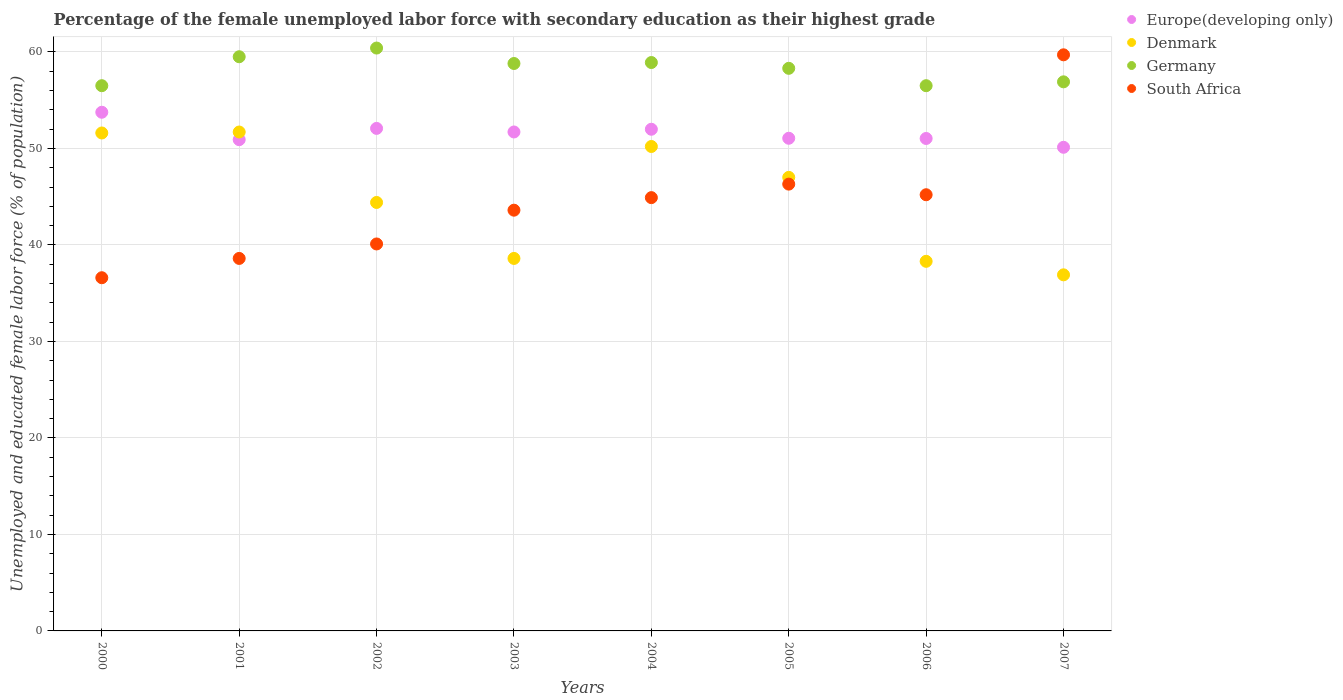What is the percentage of the unemployed female labor force with secondary education in Europe(developing only) in 2003?
Your answer should be compact. 51.71. Across all years, what is the maximum percentage of the unemployed female labor force with secondary education in Europe(developing only)?
Keep it short and to the point. 53.75. Across all years, what is the minimum percentage of the unemployed female labor force with secondary education in Germany?
Provide a succinct answer. 56.5. In which year was the percentage of the unemployed female labor force with secondary education in South Africa maximum?
Give a very brief answer. 2007. In which year was the percentage of the unemployed female labor force with secondary education in Europe(developing only) minimum?
Your answer should be compact. 2007. What is the total percentage of the unemployed female labor force with secondary education in Germany in the graph?
Your response must be concise. 465.8. What is the difference between the percentage of the unemployed female labor force with secondary education in Denmark in 2001 and that in 2002?
Your answer should be compact. 7.3. What is the difference between the percentage of the unemployed female labor force with secondary education in South Africa in 2004 and the percentage of the unemployed female labor force with secondary education in Europe(developing only) in 2003?
Offer a terse response. -6.81. What is the average percentage of the unemployed female labor force with secondary education in Germany per year?
Your response must be concise. 58.23. In how many years, is the percentage of the unemployed female labor force with secondary education in Europe(developing only) greater than 4 %?
Offer a terse response. 8. What is the ratio of the percentage of the unemployed female labor force with secondary education in Germany in 2002 to that in 2006?
Give a very brief answer. 1.07. What is the difference between the highest and the second highest percentage of the unemployed female labor force with secondary education in South Africa?
Make the answer very short. 13.4. What is the difference between the highest and the lowest percentage of the unemployed female labor force with secondary education in Europe(developing only)?
Offer a terse response. 3.63. Is the sum of the percentage of the unemployed female labor force with secondary education in Germany in 2005 and 2006 greater than the maximum percentage of the unemployed female labor force with secondary education in Denmark across all years?
Offer a terse response. Yes. Is it the case that in every year, the sum of the percentage of the unemployed female labor force with secondary education in Denmark and percentage of the unemployed female labor force with secondary education in South Africa  is greater than the sum of percentage of the unemployed female labor force with secondary education in Germany and percentage of the unemployed female labor force with secondary education in Europe(developing only)?
Provide a succinct answer. Yes. Is it the case that in every year, the sum of the percentage of the unemployed female labor force with secondary education in South Africa and percentage of the unemployed female labor force with secondary education in Europe(developing only)  is greater than the percentage of the unemployed female labor force with secondary education in Denmark?
Offer a very short reply. Yes. Does the percentage of the unemployed female labor force with secondary education in Germany monotonically increase over the years?
Your answer should be compact. No. Is the percentage of the unemployed female labor force with secondary education in Denmark strictly greater than the percentage of the unemployed female labor force with secondary education in South Africa over the years?
Offer a very short reply. No. How many years are there in the graph?
Your response must be concise. 8. What is the difference between two consecutive major ticks on the Y-axis?
Make the answer very short. 10. Does the graph contain any zero values?
Make the answer very short. No. What is the title of the graph?
Your answer should be very brief. Percentage of the female unemployed labor force with secondary education as their highest grade. What is the label or title of the X-axis?
Your response must be concise. Years. What is the label or title of the Y-axis?
Make the answer very short. Unemployed and educated female labor force (% of population). What is the Unemployed and educated female labor force (% of population) of Europe(developing only) in 2000?
Ensure brevity in your answer.  53.75. What is the Unemployed and educated female labor force (% of population) of Denmark in 2000?
Your answer should be very brief. 51.6. What is the Unemployed and educated female labor force (% of population) of Germany in 2000?
Provide a succinct answer. 56.5. What is the Unemployed and educated female labor force (% of population) of South Africa in 2000?
Keep it short and to the point. 36.6. What is the Unemployed and educated female labor force (% of population) in Europe(developing only) in 2001?
Provide a succinct answer. 50.91. What is the Unemployed and educated female labor force (% of population) in Denmark in 2001?
Ensure brevity in your answer.  51.7. What is the Unemployed and educated female labor force (% of population) of Germany in 2001?
Give a very brief answer. 59.5. What is the Unemployed and educated female labor force (% of population) of South Africa in 2001?
Give a very brief answer. 38.6. What is the Unemployed and educated female labor force (% of population) of Europe(developing only) in 2002?
Your response must be concise. 52.07. What is the Unemployed and educated female labor force (% of population) in Denmark in 2002?
Your answer should be compact. 44.4. What is the Unemployed and educated female labor force (% of population) in Germany in 2002?
Your answer should be compact. 60.4. What is the Unemployed and educated female labor force (% of population) of South Africa in 2002?
Your answer should be compact. 40.1. What is the Unemployed and educated female labor force (% of population) in Europe(developing only) in 2003?
Offer a very short reply. 51.71. What is the Unemployed and educated female labor force (% of population) of Denmark in 2003?
Offer a terse response. 38.6. What is the Unemployed and educated female labor force (% of population) in Germany in 2003?
Make the answer very short. 58.8. What is the Unemployed and educated female labor force (% of population) in South Africa in 2003?
Give a very brief answer. 43.6. What is the Unemployed and educated female labor force (% of population) of Europe(developing only) in 2004?
Keep it short and to the point. 51.99. What is the Unemployed and educated female labor force (% of population) in Denmark in 2004?
Offer a terse response. 50.2. What is the Unemployed and educated female labor force (% of population) of Germany in 2004?
Provide a succinct answer. 58.9. What is the Unemployed and educated female labor force (% of population) of South Africa in 2004?
Give a very brief answer. 44.9. What is the Unemployed and educated female labor force (% of population) in Europe(developing only) in 2005?
Make the answer very short. 51.05. What is the Unemployed and educated female labor force (% of population) in Germany in 2005?
Your answer should be compact. 58.3. What is the Unemployed and educated female labor force (% of population) of South Africa in 2005?
Give a very brief answer. 46.3. What is the Unemployed and educated female labor force (% of population) in Europe(developing only) in 2006?
Keep it short and to the point. 51.03. What is the Unemployed and educated female labor force (% of population) in Denmark in 2006?
Ensure brevity in your answer.  38.3. What is the Unemployed and educated female labor force (% of population) in Germany in 2006?
Offer a very short reply. 56.5. What is the Unemployed and educated female labor force (% of population) of South Africa in 2006?
Make the answer very short. 45.2. What is the Unemployed and educated female labor force (% of population) in Europe(developing only) in 2007?
Ensure brevity in your answer.  50.12. What is the Unemployed and educated female labor force (% of population) of Denmark in 2007?
Your answer should be very brief. 36.9. What is the Unemployed and educated female labor force (% of population) in Germany in 2007?
Ensure brevity in your answer.  56.9. What is the Unemployed and educated female labor force (% of population) of South Africa in 2007?
Provide a succinct answer. 59.7. Across all years, what is the maximum Unemployed and educated female labor force (% of population) of Europe(developing only)?
Your answer should be compact. 53.75. Across all years, what is the maximum Unemployed and educated female labor force (% of population) of Denmark?
Make the answer very short. 51.7. Across all years, what is the maximum Unemployed and educated female labor force (% of population) in Germany?
Provide a succinct answer. 60.4. Across all years, what is the maximum Unemployed and educated female labor force (% of population) in South Africa?
Keep it short and to the point. 59.7. Across all years, what is the minimum Unemployed and educated female labor force (% of population) of Europe(developing only)?
Keep it short and to the point. 50.12. Across all years, what is the minimum Unemployed and educated female labor force (% of population) in Denmark?
Your response must be concise. 36.9. Across all years, what is the minimum Unemployed and educated female labor force (% of population) in Germany?
Make the answer very short. 56.5. Across all years, what is the minimum Unemployed and educated female labor force (% of population) of South Africa?
Make the answer very short. 36.6. What is the total Unemployed and educated female labor force (% of population) in Europe(developing only) in the graph?
Make the answer very short. 412.62. What is the total Unemployed and educated female labor force (% of population) of Denmark in the graph?
Give a very brief answer. 358.7. What is the total Unemployed and educated female labor force (% of population) in Germany in the graph?
Give a very brief answer. 465.8. What is the total Unemployed and educated female labor force (% of population) of South Africa in the graph?
Offer a terse response. 355. What is the difference between the Unemployed and educated female labor force (% of population) of Europe(developing only) in 2000 and that in 2001?
Offer a very short reply. 2.84. What is the difference between the Unemployed and educated female labor force (% of population) of Germany in 2000 and that in 2001?
Make the answer very short. -3. What is the difference between the Unemployed and educated female labor force (% of population) of South Africa in 2000 and that in 2001?
Offer a terse response. -2. What is the difference between the Unemployed and educated female labor force (% of population) in Europe(developing only) in 2000 and that in 2002?
Ensure brevity in your answer.  1.67. What is the difference between the Unemployed and educated female labor force (% of population) in Denmark in 2000 and that in 2002?
Your answer should be very brief. 7.2. What is the difference between the Unemployed and educated female labor force (% of population) in Germany in 2000 and that in 2002?
Provide a succinct answer. -3.9. What is the difference between the Unemployed and educated female labor force (% of population) of Europe(developing only) in 2000 and that in 2003?
Your answer should be very brief. 2.04. What is the difference between the Unemployed and educated female labor force (% of population) in Denmark in 2000 and that in 2003?
Provide a short and direct response. 13. What is the difference between the Unemployed and educated female labor force (% of population) of South Africa in 2000 and that in 2003?
Keep it short and to the point. -7. What is the difference between the Unemployed and educated female labor force (% of population) of Europe(developing only) in 2000 and that in 2004?
Your response must be concise. 1.76. What is the difference between the Unemployed and educated female labor force (% of population) of Germany in 2000 and that in 2004?
Your answer should be very brief. -2.4. What is the difference between the Unemployed and educated female labor force (% of population) in South Africa in 2000 and that in 2004?
Offer a very short reply. -8.3. What is the difference between the Unemployed and educated female labor force (% of population) in Europe(developing only) in 2000 and that in 2005?
Offer a terse response. 2.7. What is the difference between the Unemployed and educated female labor force (% of population) of Europe(developing only) in 2000 and that in 2006?
Keep it short and to the point. 2.72. What is the difference between the Unemployed and educated female labor force (% of population) of Europe(developing only) in 2000 and that in 2007?
Make the answer very short. 3.63. What is the difference between the Unemployed and educated female labor force (% of population) in Denmark in 2000 and that in 2007?
Offer a very short reply. 14.7. What is the difference between the Unemployed and educated female labor force (% of population) in Germany in 2000 and that in 2007?
Ensure brevity in your answer.  -0.4. What is the difference between the Unemployed and educated female labor force (% of population) of South Africa in 2000 and that in 2007?
Offer a very short reply. -23.1. What is the difference between the Unemployed and educated female labor force (% of population) of Europe(developing only) in 2001 and that in 2002?
Provide a short and direct response. -1.17. What is the difference between the Unemployed and educated female labor force (% of population) of South Africa in 2001 and that in 2002?
Provide a short and direct response. -1.5. What is the difference between the Unemployed and educated female labor force (% of population) of Europe(developing only) in 2001 and that in 2003?
Offer a very short reply. -0.8. What is the difference between the Unemployed and educated female labor force (% of population) in Denmark in 2001 and that in 2003?
Your response must be concise. 13.1. What is the difference between the Unemployed and educated female labor force (% of population) of Europe(developing only) in 2001 and that in 2004?
Give a very brief answer. -1.08. What is the difference between the Unemployed and educated female labor force (% of population) in South Africa in 2001 and that in 2004?
Offer a very short reply. -6.3. What is the difference between the Unemployed and educated female labor force (% of population) of Europe(developing only) in 2001 and that in 2005?
Your answer should be compact. -0.15. What is the difference between the Unemployed and educated female labor force (% of population) of Germany in 2001 and that in 2005?
Offer a very short reply. 1.2. What is the difference between the Unemployed and educated female labor force (% of population) in Europe(developing only) in 2001 and that in 2006?
Your response must be concise. -0.12. What is the difference between the Unemployed and educated female labor force (% of population) in Germany in 2001 and that in 2006?
Offer a terse response. 3. What is the difference between the Unemployed and educated female labor force (% of population) of Europe(developing only) in 2001 and that in 2007?
Make the answer very short. 0.79. What is the difference between the Unemployed and educated female labor force (% of population) in South Africa in 2001 and that in 2007?
Your answer should be compact. -21.1. What is the difference between the Unemployed and educated female labor force (% of population) in Europe(developing only) in 2002 and that in 2003?
Your answer should be very brief. 0.37. What is the difference between the Unemployed and educated female labor force (% of population) of Denmark in 2002 and that in 2003?
Make the answer very short. 5.8. What is the difference between the Unemployed and educated female labor force (% of population) in Europe(developing only) in 2002 and that in 2004?
Provide a short and direct response. 0.09. What is the difference between the Unemployed and educated female labor force (% of population) in Germany in 2002 and that in 2004?
Offer a terse response. 1.5. What is the difference between the Unemployed and educated female labor force (% of population) in Denmark in 2002 and that in 2005?
Keep it short and to the point. -2.6. What is the difference between the Unemployed and educated female labor force (% of population) in Germany in 2002 and that in 2005?
Your response must be concise. 2.1. What is the difference between the Unemployed and educated female labor force (% of population) of South Africa in 2002 and that in 2005?
Your answer should be compact. -6.2. What is the difference between the Unemployed and educated female labor force (% of population) in Europe(developing only) in 2002 and that in 2006?
Your answer should be compact. 1.04. What is the difference between the Unemployed and educated female labor force (% of population) in Germany in 2002 and that in 2006?
Provide a succinct answer. 3.9. What is the difference between the Unemployed and educated female labor force (% of population) in Europe(developing only) in 2002 and that in 2007?
Offer a terse response. 1.96. What is the difference between the Unemployed and educated female labor force (% of population) of Denmark in 2002 and that in 2007?
Keep it short and to the point. 7.5. What is the difference between the Unemployed and educated female labor force (% of population) in South Africa in 2002 and that in 2007?
Keep it short and to the point. -19.6. What is the difference between the Unemployed and educated female labor force (% of population) in Europe(developing only) in 2003 and that in 2004?
Offer a very short reply. -0.28. What is the difference between the Unemployed and educated female labor force (% of population) in South Africa in 2003 and that in 2004?
Offer a terse response. -1.3. What is the difference between the Unemployed and educated female labor force (% of population) of Europe(developing only) in 2003 and that in 2005?
Offer a terse response. 0.65. What is the difference between the Unemployed and educated female labor force (% of population) of Europe(developing only) in 2003 and that in 2006?
Give a very brief answer. 0.67. What is the difference between the Unemployed and educated female labor force (% of population) of South Africa in 2003 and that in 2006?
Give a very brief answer. -1.6. What is the difference between the Unemployed and educated female labor force (% of population) in Europe(developing only) in 2003 and that in 2007?
Give a very brief answer. 1.59. What is the difference between the Unemployed and educated female labor force (% of population) in South Africa in 2003 and that in 2007?
Give a very brief answer. -16.1. What is the difference between the Unemployed and educated female labor force (% of population) of Europe(developing only) in 2004 and that in 2005?
Provide a succinct answer. 0.93. What is the difference between the Unemployed and educated female labor force (% of population) of South Africa in 2004 and that in 2005?
Offer a very short reply. -1.4. What is the difference between the Unemployed and educated female labor force (% of population) in Europe(developing only) in 2004 and that in 2006?
Give a very brief answer. 0.96. What is the difference between the Unemployed and educated female labor force (% of population) in Germany in 2004 and that in 2006?
Give a very brief answer. 2.4. What is the difference between the Unemployed and educated female labor force (% of population) of Europe(developing only) in 2004 and that in 2007?
Offer a terse response. 1.87. What is the difference between the Unemployed and educated female labor force (% of population) of Denmark in 2004 and that in 2007?
Provide a short and direct response. 13.3. What is the difference between the Unemployed and educated female labor force (% of population) in South Africa in 2004 and that in 2007?
Your answer should be compact. -14.8. What is the difference between the Unemployed and educated female labor force (% of population) of Europe(developing only) in 2005 and that in 2006?
Your answer should be very brief. 0.02. What is the difference between the Unemployed and educated female labor force (% of population) of Denmark in 2005 and that in 2006?
Make the answer very short. 8.7. What is the difference between the Unemployed and educated female labor force (% of population) in Germany in 2005 and that in 2006?
Offer a terse response. 1.8. What is the difference between the Unemployed and educated female labor force (% of population) in Europe(developing only) in 2005 and that in 2007?
Keep it short and to the point. 0.94. What is the difference between the Unemployed and educated female labor force (% of population) of Germany in 2005 and that in 2007?
Offer a very short reply. 1.4. What is the difference between the Unemployed and educated female labor force (% of population) of South Africa in 2005 and that in 2007?
Provide a short and direct response. -13.4. What is the difference between the Unemployed and educated female labor force (% of population) of Europe(developing only) in 2006 and that in 2007?
Give a very brief answer. 0.91. What is the difference between the Unemployed and educated female labor force (% of population) in Europe(developing only) in 2000 and the Unemployed and educated female labor force (% of population) in Denmark in 2001?
Provide a short and direct response. 2.05. What is the difference between the Unemployed and educated female labor force (% of population) of Europe(developing only) in 2000 and the Unemployed and educated female labor force (% of population) of Germany in 2001?
Provide a succinct answer. -5.75. What is the difference between the Unemployed and educated female labor force (% of population) in Europe(developing only) in 2000 and the Unemployed and educated female labor force (% of population) in South Africa in 2001?
Your answer should be compact. 15.15. What is the difference between the Unemployed and educated female labor force (% of population) in Denmark in 2000 and the Unemployed and educated female labor force (% of population) in South Africa in 2001?
Give a very brief answer. 13. What is the difference between the Unemployed and educated female labor force (% of population) of Europe(developing only) in 2000 and the Unemployed and educated female labor force (% of population) of Denmark in 2002?
Offer a very short reply. 9.35. What is the difference between the Unemployed and educated female labor force (% of population) in Europe(developing only) in 2000 and the Unemployed and educated female labor force (% of population) in Germany in 2002?
Your response must be concise. -6.65. What is the difference between the Unemployed and educated female labor force (% of population) in Europe(developing only) in 2000 and the Unemployed and educated female labor force (% of population) in South Africa in 2002?
Offer a very short reply. 13.65. What is the difference between the Unemployed and educated female labor force (% of population) in Europe(developing only) in 2000 and the Unemployed and educated female labor force (% of population) in Denmark in 2003?
Offer a terse response. 15.15. What is the difference between the Unemployed and educated female labor force (% of population) in Europe(developing only) in 2000 and the Unemployed and educated female labor force (% of population) in Germany in 2003?
Your answer should be compact. -5.05. What is the difference between the Unemployed and educated female labor force (% of population) of Europe(developing only) in 2000 and the Unemployed and educated female labor force (% of population) of South Africa in 2003?
Offer a terse response. 10.15. What is the difference between the Unemployed and educated female labor force (% of population) of Denmark in 2000 and the Unemployed and educated female labor force (% of population) of South Africa in 2003?
Offer a terse response. 8. What is the difference between the Unemployed and educated female labor force (% of population) of Europe(developing only) in 2000 and the Unemployed and educated female labor force (% of population) of Denmark in 2004?
Give a very brief answer. 3.55. What is the difference between the Unemployed and educated female labor force (% of population) in Europe(developing only) in 2000 and the Unemployed and educated female labor force (% of population) in Germany in 2004?
Make the answer very short. -5.15. What is the difference between the Unemployed and educated female labor force (% of population) in Europe(developing only) in 2000 and the Unemployed and educated female labor force (% of population) in South Africa in 2004?
Make the answer very short. 8.85. What is the difference between the Unemployed and educated female labor force (% of population) in Germany in 2000 and the Unemployed and educated female labor force (% of population) in South Africa in 2004?
Offer a very short reply. 11.6. What is the difference between the Unemployed and educated female labor force (% of population) in Europe(developing only) in 2000 and the Unemployed and educated female labor force (% of population) in Denmark in 2005?
Your response must be concise. 6.75. What is the difference between the Unemployed and educated female labor force (% of population) of Europe(developing only) in 2000 and the Unemployed and educated female labor force (% of population) of Germany in 2005?
Offer a very short reply. -4.55. What is the difference between the Unemployed and educated female labor force (% of population) in Europe(developing only) in 2000 and the Unemployed and educated female labor force (% of population) in South Africa in 2005?
Offer a terse response. 7.45. What is the difference between the Unemployed and educated female labor force (% of population) of Denmark in 2000 and the Unemployed and educated female labor force (% of population) of Germany in 2005?
Offer a very short reply. -6.7. What is the difference between the Unemployed and educated female labor force (% of population) in Germany in 2000 and the Unemployed and educated female labor force (% of population) in South Africa in 2005?
Make the answer very short. 10.2. What is the difference between the Unemployed and educated female labor force (% of population) of Europe(developing only) in 2000 and the Unemployed and educated female labor force (% of population) of Denmark in 2006?
Give a very brief answer. 15.45. What is the difference between the Unemployed and educated female labor force (% of population) of Europe(developing only) in 2000 and the Unemployed and educated female labor force (% of population) of Germany in 2006?
Your answer should be compact. -2.75. What is the difference between the Unemployed and educated female labor force (% of population) in Europe(developing only) in 2000 and the Unemployed and educated female labor force (% of population) in South Africa in 2006?
Ensure brevity in your answer.  8.55. What is the difference between the Unemployed and educated female labor force (% of population) in Denmark in 2000 and the Unemployed and educated female labor force (% of population) in Germany in 2006?
Your answer should be very brief. -4.9. What is the difference between the Unemployed and educated female labor force (% of population) of Denmark in 2000 and the Unemployed and educated female labor force (% of population) of South Africa in 2006?
Your answer should be very brief. 6.4. What is the difference between the Unemployed and educated female labor force (% of population) in Europe(developing only) in 2000 and the Unemployed and educated female labor force (% of population) in Denmark in 2007?
Ensure brevity in your answer.  16.85. What is the difference between the Unemployed and educated female labor force (% of population) of Europe(developing only) in 2000 and the Unemployed and educated female labor force (% of population) of Germany in 2007?
Make the answer very short. -3.15. What is the difference between the Unemployed and educated female labor force (% of population) of Europe(developing only) in 2000 and the Unemployed and educated female labor force (% of population) of South Africa in 2007?
Your response must be concise. -5.95. What is the difference between the Unemployed and educated female labor force (% of population) of Denmark in 2000 and the Unemployed and educated female labor force (% of population) of South Africa in 2007?
Offer a terse response. -8.1. What is the difference between the Unemployed and educated female labor force (% of population) of Europe(developing only) in 2001 and the Unemployed and educated female labor force (% of population) of Denmark in 2002?
Provide a succinct answer. 6.51. What is the difference between the Unemployed and educated female labor force (% of population) of Europe(developing only) in 2001 and the Unemployed and educated female labor force (% of population) of Germany in 2002?
Provide a succinct answer. -9.49. What is the difference between the Unemployed and educated female labor force (% of population) of Europe(developing only) in 2001 and the Unemployed and educated female labor force (% of population) of South Africa in 2002?
Offer a very short reply. 10.81. What is the difference between the Unemployed and educated female labor force (% of population) of Europe(developing only) in 2001 and the Unemployed and educated female labor force (% of population) of Denmark in 2003?
Ensure brevity in your answer.  12.31. What is the difference between the Unemployed and educated female labor force (% of population) of Europe(developing only) in 2001 and the Unemployed and educated female labor force (% of population) of Germany in 2003?
Offer a terse response. -7.89. What is the difference between the Unemployed and educated female labor force (% of population) of Europe(developing only) in 2001 and the Unemployed and educated female labor force (% of population) of South Africa in 2003?
Provide a short and direct response. 7.31. What is the difference between the Unemployed and educated female labor force (% of population) in Denmark in 2001 and the Unemployed and educated female labor force (% of population) in South Africa in 2003?
Ensure brevity in your answer.  8.1. What is the difference between the Unemployed and educated female labor force (% of population) in Europe(developing only) in 2001 and the Unemployed and educated female labor force (% of population) in Denmark in 2004?
Give a very brief answer. 0.71. What is the difference between the Unemployed and educated female labor force (% of population) of Europe(developing only) in 2001 and the Unemployed and educated female labor force (% of population) of Germany in 2004?
Provide a short and direct response. -7.99. What is the difference between the Unemployed and educated female labor force (% of population) of Europe(developing only) in 2001 and the Unemployed and educated female labor force (% of population) of South Africa in 2004?
Provide a succinct answer. 6.01. What is the difference between the Unemployed and educated female labor force (% of population) of Denmark in 2001 and the Unemployed and educated female labor force (% of population) of South Africa in 2004?
Your response must be concise. 6.8. What is the difference between the Unemployed and educated female labor force (% of population) in Germany in 2001 and the Unemployed and educated female labor force (% of population) in South Africa in 2004?
Provide a succinct answer. 14.6. What is the difference between the Unemployed and educated female labor force (% of population) of Europe(developing only) in 2001 and the Unemployed and educated female labor force (% of population) of Denmark in 2005?
Your answer should be compact. 3.91. What is the difference between the Unemployed and educated female labor force (% of population) in Europe(developing only) in 2001 and the Unemployed and educated female labor force (% of population) in Germany in 2005?
Keep it short and to the point. -7.39. What is the difference between the Unemployed and educated female labor force (% of population) of Europe(developing only) in 2001 and the Unemployed and educated female labor force (% of population) of South Africa in 2005?
Your response must be concise. 4.61. What is the difference between the Unemployed and educated female labor force (% of population) of Germany in 2001 and the Unemployed and educated female labor force (% of population) of South Africa in 2005?
Ensure brevity in your answer.  13.2. What is the difference between the Unemployed and educated female labor force (% of population) of Europe(developing only) in 2001 and the Unemployed and educated female labor force (% of population) of Denmark in 2006?
Keep it short and to the point. 12.61. What is the difference between the Unemployed and educated female labor force (% of population) in Europe(developing only) in 2001 and the Unemployed and educated female labor force (% of population) in Germany in 2006?
Your answer should be very brief. -5.59. What is the difference between the Unemployed and educated female labor force (% of population) in Europe(developing only) in 2001 and the Unemployed and educated female labor force (% of population) in South Africa in 2006?
Your response must be concise. 5.71. What is the difference between the Unemployed and educated female labor force (% of population) in Europe(developing only) in 2001 and the Unemployed and educated female labor force (% of population) in Denmark in 2007?
Give a very brief answer. 14.01. What is the difference between the Unemployed and educated female labor force (% of population) in Europe(developing only) in 2001 and the Unemployed and educated female labor force (% of population) in Germany in 2007?
Keep it short and to the point. -5.99. What is the difference between the Unemployed and educated female labor force (% of population) in Europe(developing only) in 2001 and the Unemployed and educated female labor force (% of population) in South Africa in 2007?
Provide a short and direct response. -8.79. What is the difference between the Unemployed and educated female labor force (% of population) in Germany in 2001 and the Unemployed and educated female labor force (% of population) in South Africa in 2007?
Offer a terse response. -0.2. What is the difference between the Unemployed and educated female labor force (% of population) in Europe(developing only) in 2002 and the Unemployed and educated female labor force (% of population) in Denmark in 2003?
Give a very brief answer. 13.47. What is the difference between the Unemployed and educated female labor force (% of population) of Europe(developing only) in 2002 and the Unemployed and educated female labor force (% of population) of Germany in 2003?
Keep it short and to the point. -6.73. What is the difference between the Unemployed and educated female labor force (% of population) in Europe(developing only) in 2002 and the Unemployed and educated female labor force (% of population) in South Africa in 2003?
Provide a short and direct response. 8.47. What is the difference between the Unemployed and educated female labor force (% of population) in Denmark in 2002 and the Unemployed and educated female labor force (% of population) in Germany in 2003?
Provide a succinct answer. -14.4. What is the difference between the Unemployed and educated female labor force (% of population) in Germany in 2002 and the Unemployed and educated female labor force (% of population) in South Africa in 2003?
Provide a short and direct response. 16.8. What is the difference between the Unemployed and educated female labor force (% of population) in Europe(developing only) in 2002 and the Unemployed and educated female labor force (% of population) in Denmark in 2004?
Provide a short and direct response. 1.87. What is the difference between the Unemployed and educated female labor force (% of population) in Europe(developing only) in 2002 and the Unemployed and educated female labor force (% of population) in Germany in 2004?
Ensure brevity in your answer.  -6.83. What is the difference between the Unemployed and educated female labor force (% of population) in Europe(developing only) in 2002 and the Unemployed and educated female labor force (% of population) in South Africa in 2004?
Ensure brevity in your answer.  7.17. What is the difference between the Unemployed and educated female labor force (% of population) in Denmark in 2002 and the Unemployed and educated female labor force (% of population) in South Africa in 2004?
Provide a succinct answer. -0.5. What is the difference between the Unemployed and educated female labor force (% of population) in Germany in 2002 and the Unemployed and educated female labor force (% of population) in South Africa in 2004?
Give a very brief answer. 15.5. What is the difference between the Unemployed and educated female labor force (% of population) of Europe(developing only) in 2002 and the Unemployed and educated female labor force (% of population) of Denmark in 2005?
Provide a short and direct response. 5.07. What is the difference between the Unemployed and educated female labor force (% of population) in Europe(developing only) in 2002 and the Unemployed and educated female labor force (% of population) in Germany in 2005?
Give a very brief answer. -6.23. What is the difference between the Unemployed and educated female labor force (% of population) of Europe(developing only) in 2002 and the Unemployed and educated female labor force (% of population) of South Africa in 2005?
Provide a short and direct response. 5.77. What is the difference between the Unemployed and educated female labor force (% of population) in Denmark in 2002 and the Unemployed and educated female labor force (% of population) in Germany in 2005?
Offer a very short reply. -13.9. What is the difference between the Unemployed and educated female labor force (% of population) in Denmark in 2002 and the Unemployed and educated female labor force (% of population) in South Africa in 2005?
Keep it short and to the point. -1.9. What is the difference between the Unemployed and educated female labor force (% of population) of Germany in 2002 and the Unemployed and educated female labor force (% of population) of South Africa in 2005?
Give a very brief answer. 14.1. What is the difference between the Unemployed and educated female labor force (% of population) of Europe(developing only) in 2002 and the Unemployed and educated female labor force (% of population) of Denmark in 2006?
Your answer should be very brief. 13.77. What is the difference between the Unemployed and educated female labor force (% of population) in Europe(developing only) in 2002 and the Unemployed and educated female labor force (% of population) in Germany in 2006?
Provide a short and direct response. -4.43. What is the difference between the Unemployed and educated female labor force (% of population) of Europe(developing only) in 2002 and the Unemployed and educated female labor force (% of population) of South Africa in 2006?
Keep it short and to the point. 6.87. What is the difference between the Unemployed and educated female labor force (% of population) of Denmark in 2002 and the Unemployed and educated female labor force (% of population) of South Africa in 2006?
Give a very brief answer. -0.8. What is the difference between the Unemployed and educated female labor force (% of population) of Germany in 2002 and the Unemployed and educated female labor force (% of population) of South Africa in 2006?
Provide a short and direct response. 15.2. What is the difference between the Unemployed and educated female labor force (% of population) in Europe(developing only) in 2002 and the Unemployed and educated female labor force (% of population) in Denmark in 2007?
Your response must be concise. 15.17. What is the difference between the Unemployed and educated female labor force (% of population) in Europe(developing only) in 2002 and the Unemployed and educated female labor force (% of population) in Germany in 2007?
Provide a succinct answer. -4.83. What is the difference between the Unemployed and educated female labor force (% of population) in Europe(developing only) in 2002 and the Unemployed and educated female labor force (% of population) in South Africa in 2007?
Provide a succinct answer. -7.63. What is the difference between the Unemployed and educated female labor force (% of population) in Denmark in 2002 and the Unemployed and educated female labor force (% of population) in Germany in 2007?
Offer a very short reply. -12.5. What is the difference between the Unemployed and educated female labor force (% of population) in Denmark in 2002 and the Unemployed and educated female labor force (% of population) in South Africa in 2007?
Ensure brevity in your answer.  -15.3. What is the difference between the Unemployed and educated female labor force (% of population) in Germany in 2002 and the Unemployed and educated female labor force (% of population) in South Africa in 2007?
Provide a succinct answer. 0.7. What is the difference between the Unemployed and educated female labor force (% of population) of Europe(developing only) in 2003 and the Unemployed and educated female labor force (% of population) of Denmark in 2004?
Keep it short and to the point. 1.51. What is the difference between the Unemployed and educated female labor force (% of population) of Europe(developing only) in 2003 and the Unemployed and educated female labor force (% of population) of Germany in 2004?
Offer a terse response. -7.19. What is the difference between the Unemployed and educated female labor force (% of population) in Europe(developing only) in 2003 and the Unemployed and educated female labor force (% of population) in South Africa in 2004?
Offer a terse response. 6.81. What is the difference between the Unemployed and educated female labor force (% of population) of Denmark in 2003 and the Unemployed and educated female labor force (% of population) of Germany in 2004?
Keep it short and to the point. -20.3. What is the difference between the Unemployed and educated female labor force (% of population) of Europe(developing only) in 2003 and the Unemployed and educated female labor force (% of population) of Denmark in 2005?
Offer a very short reply. 4.71. What is the difference between the Unemployed and educated female labor force (% of population) of Europe(developing only) in 2003 and the Unemployed and educated female labor force (% of population) of Germany in 2005?
Provide a short and direct response. -6.59. What is the difference between the Unemployed and educated female labor force (% of population) of Europe(developing only) in 2003 and the Unemployed and educated female labor force (% of population) of South Africa in 2005?
Your answer should be compact. 5.41. What is the difference between the Unemployed and educated female labor force (% of population) of Denmark in 2003 and the Unemployed and educated female labor force (% of population) of Germany in 2005?
Keep it short and to the point. -19.7. What is the difference between the Unemployed and educated female labor force (% of population) in Denmark in 2003 and the Unemployed and educated female labor force (% of population) in South Africa in 2005?
Make the answer very short. -7.7. What is the difference between the Unemployed and educated female labor force (% of population) in Europe(developing only) in 2003 and the Unemployed and educated female labor force (% of population) in Denmark in 2006?
Your answer should be very brief. 13.41. What is the difference between the Unemployed and educated female labor force (% of population) in Europe(developing only) in 2003 and the Unemployed and educated female labor force (% of population) in Germany in 2006?
Offer a terse response. -4.79. What is the difference between the Unemployed and educated female labor force (% of population) of Europe(developing only) in 2003 and the Unemployed and educated female labor force (% of population) of South Africa in 2006?
Provide a succinct answer. 6.51. What is the difference between the Unemployed and educated female labor force (% of population) in Denmark in 2003 and the Unemployed and educated female labor force (% of population) in Germany in 2006?
Keep it short and to the point. -17.9. What is the difference between the Unemployed and educated female labor force (% of population) in Europe(developing only) in 2003 and the Unemployed and educated female labor force (% of population) in Denmark in 2007?
Provide a succinct answer. 14.81. What is the difference between the Unemployed and educated female labor force (% of population) in Europe(developing only) in 2003 and the Unemployed and educated female labor force (% of population) in Germany in 2007?
Keep it short and to the point. -5.19. What is the difference between the Unemployed and educated female labor force (% of population) in Europe(developing only) in 2003 and the Unemployed and educated female labor force (% of population) in South Africa in 2007?
Give a very brief answer. -7.99. What is the difference between the Unemployed and educated female labor force (% of population) in Denmark in 2003 and the Unemployed and educated female labor force (% of population) in Germany in 2007?
Your answer should be compact. -18.3. What is the difference between the Unemployed and educated female labor force (% of population) in Denmark in 2003 and the Unemployed and educated female labor force (% of population) in South Africa in 2007?
Your answer should be compact. -21.1. What is the difference between the Unemployed and educated female labor force (% of population) in Europe(developing only) in 2004 and the Unemployed and educated female labor force (% of population) in Denmark in 2005?
Offer a very short reply. 4.99. What is the difference between the Unemployed and educated female labor force (% of population) of Europe(developing only) in 2004 and the Unemployed and educated female labor force (% of population) of Germany in 2005?
Offer a very short reply. -6.31. What is the difference between the Unemployed and educated female labor force (% of population) in Europe(developing only) in 2004 and the Unemployed and educated female labor force (% of population) in South Africa in 2005?
Ensure brevity in your answer.  5.69. What is the difference between the Unemployed and educated female labor force (% of population) of Denmark in 2004 and the Unemployed and educated female labor force (% of population) of South Africa in 2005?
Your response must be concise. 3.9. What is the difference between the Unemployed and educated female labor force (% of population) of Europe(developing only) in 2004 and the Unemployed and educated female labor force (% of population) of Denmark in 2006?
Your answer should be compact. 13.69. What is the difference between the Unemployed and educated female labor force (% of population) in Europe(developing only) in 2004 and the Unemployed and educated female labor force (% of population) in Germany in 2006?
Keep it short and to the point. -4.51. What is the difference between the Unemployed and educated female labor force (% of population) in Europe(developing only) in 2004 and the Unemployed and educated female labor force (% of population) in South Africa in 2006?
Your response must be concise. 6.79. What is the difference between the Unemployed and educated female labor force (% of population) in Europe(developing only) in 2004 and the Unemployed and educated female labor force (% of population) in Denmark in 2007?
Your answer should be compact. 15.09. What is the difference between the Unemployed and educated female labor force (% of population) of Europe(developing only) in 2004 and the Unemployed and educated female labor force (% of population) of Germany in 2007?
Give a very brief answer. -4.91. What is the difference between the Unemployed and educated female labor force (% of population) of Europe(developing only) in 2004 and the Unemployed and educated female labor force (% of population) of South Africa in 2007?
Make the answer very short. -7.71. What is the difference between the Unemployed and educated female labor force (% of population) in Denmark in 2004 and the Unemployed and educated female labor force (% of population) in Germany in 2007?
Offer a very short reply. -6.7. What is the difference between the Unemployed and educated female labor force (% of population) in Denmark in 2004 and the Unemployed and educated female labor force (% of population) in South Africa in 2007?
Keep it short and to the point. -9.5. What is the difference between the Unemployed and educated female labor force (% of population) of Germany in 2004 and the Unemployed and educated female labor force (% of population) of South Africa in 2007?
Your response must be concise. -0.8. What is the difference between the Unemployed and educated female labor force (% of population) of Europe(developing only) in 2005 and the Unemployed and educated female labor force (% of population) of Denmark in 2006?
Ensure brevity in your answer.  12.75. What is the difference between the Unemployed and educated female labor force (% of population) of Europe(developing only) in 2005 and the Unemployed and educated female labor force (% of population) of Germany in 2006?
Offer a very short reply. -5.45. What is the difference between the Unemployed and educated female labor force (% of population) in Europe(developing only) in 2005 and the Unemployed and educated female labor force (% of population) in South Africa in 2006?
Offer a terse response. 5.85. What is the difference between the Unemployed and educated female labor force (% of population) in Europe(developing only) in 2005 and the Unemployed and educated female labor force (% of population) in Denmark in 2007?
Offer a very short reply. 14.15. What is the difference between the Unemployed and educated female labor force (% of population) of Europe(developing only) in 2005 and the Unemployed and educated female labor force (% of population) of Germany in 2007?
Your answer should be very brief. -5.85. What is the difference between the Unemployed and educated female labor force (% of population) of Europe(developing only) in 2005 and the Unemployed and educated female labor force (% of population) of South Africa in 2007?
Offer a very short reply. -8.65. What is the difference between the Unemployed and educated female labor force (% of population) in Denmark in 2005 and the Unemployed and educated female labor force (% of population) in Germany in 2007?
Give a very brief answer. -9.9. What is the difference between the Unemployed and educated female labor force (% of population) of Denmark in 2005 and the Unemployed and educated female labor force (% of population) of South Africa in 2007?
Offer a very short reply. -12.7. What is the difference between the Unemployed and educated female labor force (% of population) in Europe(developing only) in 2006 and the Unemployed and educated female labor force (% of population) in Denmark in 2007?
Provide a short and direct response. 14.13. What is the difference between the Unemployed and educated female labor force (% of population) of Europe(developing only) in 2006 and the Unemployed and educated female labor force (% of population) of Germany in 2007?
Keep it short and to the point. -5.87. What is the difference between the Unemployed and educated female labor force (% of population) of Europe(developing only) in 2006 and the Unemployed and educated female labor force (% of population) of South Africa in 2007?
Keep it short and to the point. -8.67. What is the difference between the Unemployed and educated female labor force (% of population) of Denmark in 2006 and the Unemployed and educated female labor force (% of population) of Germany in 2007?
Provide a short and direct response. -18.6. What is the difference between the Unemployed and educated female labor force (% of population) in Denmark in 2006 and the Unemployed and educated female labor force (% of population) in South Africa in 2007?
Give a very brief answer. -21.4. What is the average Unemployed and educated female labor force (% of population) in Europe(developing only) per year?
Your answer should be compact. 51.58. What is the average Unemployed and educated female labor force (% of population) of Denmark per year?
Provide a short and direct response. 44.84. What is the average Unemployed and educated female labor force (% of population) in Germany per year?
Your response must be concise. 58.23. What is the average Unemployed and educated female labor force (% of population) in South Africa per year?
Keep it short and to the point. 44.38. In the year 2000, what is the difference between the Unemployed and educated female labor force (% of population) in Europe(developing only) and Unemployed and educated female labor force (% of population) in Denmark?
Keep it short and to the point. 2.15. In the year 2000, what is the difference between the Unemployed and educated female labor force (% of population) in Europe(developing only) and Unemployed and educated female labor force (% of population) in Germany?
Provide a short and direct response. -2.75. In the year 2000, what is the difference between the Unemployed and educated female labor force (% of population) of Europe(developing only) and Unemployed and educated female labor force (% of population) of South Africa?
Make the answer very short. 17.15. In the year 2000, what is the difference between the Unemployed and educated female labor force (% of population) in Germany and Unemployed and educated female labor force (% of population) in South Africa?
Ensure brevity in your answer.  19.9. In the year 2001, what is the difference between the Unemployed and educated female labor force (% of population) in Europe(developing only) and Unemployed and educated female labor force (% of population) in Denmark?
Your answer should be very brief. -0.79. In the year 2001, what is the difference between the Unemployed and educated female labor force (% of population) of Europe(developing only) and Unemployed and educated female labor force (% of population) of Germany?
Give a very brief answer. -8.59. In the year 2001, what is the difference between the Unemployed and educated female labor force (% of population) in Europe(developing only) and Unemployed and educated female labor force (% of population) in South Africa?
Give a very brief answer. 12.31. In the year 2001, what is the difference between the Unemployed and educated female labor force (% of population) in Germany and Unemployed and educated female labor force (% of population) in South Africa?
Your answer should be compact. 20.9. In the year 2002, what is the difference between the Unemployed and educated female labor force (% of population) of Europe(developing only) and Unemployed and educated female labor force (% of population) of Denmark?
Your answer should be very brief. 7.67. In the year 2002, what is the difference between the Unemployed and educated female labor force (% of population) of Europe(developing only) and Unemployed and educated female labor force (% of population) of Germany?
Your answer should be compact. -8.33. In the year 2002, what is the difference between the Unemployed and educated female labor force (% of population) in Europe(developing only) and Unemployed and educated female labor force (% of population) in South Africa?
Keep it short and to the point. 11.97. In the year 2002, what is the difference between the Unemployed and educated female labor force (% of population) of Denmark and Unemployed and educated female labor force (% of population) of South Africa?
Offer a very short reply. 4.3. In the year 2002, what is the difference between the Unemployed and educated female labor force (% of population) in Germany and Unemployed and educated female labor force (% of population) in South Africa?
Make the answer very short. 20.3. In the year 2003, what is the difference between the Unemployed and educated female labor force (% of population) of Europe(developing only) and Unemployed and educated female labor force (% of population) of Denmark?
Offer a terse response. 13.11. In the year 2003, what is the difference between the Unemployed and educated female labor force (% of population) of Europe(developing only) and Unemployed and educated female labor force (% of population) of Germany?
Your answer should be compact. -7.09. In the year 2003, what is the difference between the Unemployed and educated female labor force (% of population) in Europe(developing only) and Unemployed and educated female labor force (% of population) in South Africa?
Make the answer very short. 8.11. In the year 2003, what is the difference between the Unemployed and educated female labor force (% of population) of Denmark and Unemployed and educated female labor force (% of population) of Germany?
Make the answer very short. -20.2. In the year 2003, what is the difference between the Unemployed and educated female labor force (% of population) of Germany and Unemployed and educated female labor force (% of population) of South Africa?
Your answer should be compact. 15.2. In the year 2004, what is the difference between the Unemployed and educated female labor force (% of population) in Europe(developing only) and Unemployed and educated female labor force (% of population) in Denmark?
Ensure brevity in your answer.  1.79. In the year 2004, what is the difference between the Unemployed and educated female labor force (% of population) in Europe(developing only) and Unemployed and educated female labor force (% of population) in Germany?
Make the answer very short. -6.91. In the year 2004, what is the difference between the Unemployed and educated female labor force (% of population) of Europe(developing only) and Unemployed and educated female labor force (% of population) of South Africa?
Provide a short and direct response. 7.09. In the year 2004, what is the difference between the Unemployed and educated female labor force (% of population) of Denmark and Unemployed and educated female labor force (% of population) of Germany?
Offer a terse response. -8.7. In the year 2005, what is the difference between the Unemployed and educated female labor force (% of population) of Europe(developing only) and Unemployed and educated female labor force (% of population) of Denmark?
Provide a short and direct response. 4.05. In the year 2005, what is the difference between the Unemployed and educated female labor force (% of population) of Europe(developing only) and Unemployed and educated female labor force (% of population) of Germany?
Provide a succinct answer. -7.25. In the year 2005, what is the difference between the Unemployed and educated female labor force (% of population) in Europe(developing only) and Unemployed and educated female labor force (% of population) in South Africa?
Your answer should be very brief. 4.75. In the year 2005, what is the difference between the Unemployed and educated female labor force (% of population) of Denmark and Unemployed and educated female labor force (% of population) of Germany?
Your answer should be compact. -11.3. In the year 2005, what is the difference between the Unemployed and educated female labor force (% of population) of Denmark and Unemployed and educated female labor force (% of population) of South Africa?
Offer a terse response. 0.7. In the year 2005, what is the difference between the Unemployed and educated female labor force (% of population) of Germany and Unemployed and educated female labor force (% of population) of South Africa?
Provide a short and direct response. 12. In the year 2006, what is the difference between the Unemployed and educated female labor force (% of population) in Europe(developing only) and Unemployed and educated female labor force (% of population) in Denmark?
Keep it short and to the point. 12.73. In the year 2006, what is the difference between the Unemployed and educated female labor force (% of population) in Europe(developing only) and Unemployed and educated female labor force (% of population) in Germany?
Your answer should be very brief. -5.47. In the year 2006, what is the difference between the Unemployed and educated female labor force (% of population) in Europe(developing only) and Unemployed and educated female labor force (% of population) in South Africa?
Provide a short and direct response. 5.83. In the year 2006, what is the difference between the Unemployed and educated female labor force (% of population) of Denmark and Unemployed and educated female labor force (% of population) of Germany?
Your answer should be very brief. -18.2. In the year 2007, what is the difference between the Unemployed and educated female labor force (% of population) of Europe(developing only) and Unemployed and educated female labor force (% of population) of Denmark?
Offer a terse response. 13.22. In the year 2007, what is the difference between the Unemployed and educated female labor force (% of population) of Europe(developing only) and Unemployed and educated female labor force (% of population) of Germany?
Ensure brevity in your answer.  -6.78. In the year 2007, what is the difference between the Unemployed and educated female labor force (% of population) of Europe(developing only) and Unemployed and educated female labor force (% of population) of South Africa?
Make the answer very short. -9.58. In the year 2007, what is the difference between the Unemployed and educated female labor force (% of population) of Denmark and Unemployed and educated female labor force (% of population) of Germany?
Keep it short and to the point. -20. In the year 2007, what is the difference between the Unemployed and educated female labor force (% of population) of Denmark and Unemployed and educated female labor force (% of population) of South Africa?
Offer a terse response. -22.8. In the year 2007, what is the difference between the Unemployed and educated female labor force (% of population) in Germany and Unemployed and educated female labor force (% of population) in South Africa?
Your answer should be very brief. -2.8. What is the ratio of the Unemployed and educated female labor force (% of population) in Europe(developing only) in 2000 to that in 2001?
Provide a short and direct response. 1.06. What is the ratio of the Unemployed and educated female labor force (% of population) in Germany in 2000 to that in 2001?
Make the answer very short. 0.95. What is the ratio of the Unemployed and educated female labor force (% of population) in South Africa in 2000 to that in 2001?
Ensure brevity in your answer.  0.95. What is the ratio of the Unemployed and educated female labor force (% of population) in Europe(developing only) in 2000 to that in 2002?
Ensure brevity in your answer.  1.03. What is the ratio of the Unemployed and educated female labor force (% of population) in Denmark in 2000 to that in 2002?
Keep it short and to the point. 1.16. What is the ratio of the Unemployed and educated female labor force (% of population) of Germany in 2000 to that in 2002?
Your answer should be compact. 0.94. What is the ratio of the Unemployed and educated female labor force (% of population) in South Africa in 2000 to that in 2002?
Provide a succinct answer. 0.91. What is the ratio of the Unemployed and educated female labor force (% of population) in Europe(developing only) in 2000 to that in 2003?
Provide a succinct answer. 1.04. What is the ratio of the Unemployed and educated female labor force (% of population) in Denmark in 2000 to that in 2003?
Your response must be concise. 1.34. What is the ratio of the Unemployed and educated female labor force (% of population) of Germany in 2000 to that in 2003?
Give a very brief answer. 0.96. What is the ratio of the Unemployed and educated female labor force (% of population) in South Africa in 2000 to that in 2003?
Offer a terse response. 0.84. What is the ratio of the Unemployed and educated female labor force (% of population) of Europe(developing only) in 2000 to that in 2004?
Keep it short and to the point. 1.03. What is the ratio of the Unemployed and educated female labor force (% of population) in Denmark in 2000 to that in 2004?
Ensure brevity in your answer.  1.03. What is the ratio of the Unemployed and educated female labor force (% of population) in Germany in 2000 to that in 2004?
Offer a very short reply. 0.96. What is the ratio of the Unemployed and educated female labor force (% of population) in South Africa in 2000 to that in 2004?
Your answer should be very brief. 0.82. What is the ratio of the Unemployed and educated female labor force (% of population) in Europe(developing only) in 2000 to that in 2005?
Your answer should be compact. 1.05. What is the ratio of the Unemployed and educated female labor force (% of population) of Denmark in 2000 to that in 2005?
Provide a succinct answer. 1.1. What is the ratio of the Unemployed and educated female labor force (% of population) in Germany in 2000 to that in 2005?
Offer a terse response. 0.97. What is the ratio of the Unemployed and educated female labor force (% of population) of South Africa in 2000 to that in 2005?
Provide a short and direct response. 0.79. What is the ratio of the Unemployed and educated female labor force (% of population) of Europe(developing only) in 2000 to that in 2006?
Offer a terse response. 1.05. What is the ratio of the Unemployed and educated female labor force (% of population) in Denmark in 2000 to that in 2006?
Give a very brief answer. 1.35. What is the ratio of the Unemployed and educated female labor force (% of population) of Germany in 2000 to that in 2006?
Keep it short and to the point. 1. What is the ratio of the Unemployed and educated female labor force (% of population) in South Africa in 2000 to that in 2006?
Make the answer very short. 0.81. What is the ratio of the Unemployed and educated female labor force (% of population) in Europe(developing only) in 2000 to that in 2007?
Make the answer very short. 1.07. What is the ratio of the Unemployed and educated female labor force (% of population) in Denmark in 2000 to that in 2007?
Offer a very short reply. 1.4. What is the ratio of the Unemployed and educated female labor force (% of population) of Germany in 2000 to that in 2007?
Your response must be concise. 0.99. What is the ratio of the Unemployed and educated female labor force (% of population) in South Africa in 2000 to that in 2007?
Keep it short and to the point. 0.61. What is the ratio of the Unemployed and educated female labor force (% of population) in Europe(developing only) in 2001 to that in 2002?
Offer a terse response. 0.98. What is the ratio of the Unemployed and educated female labor force (% of population) of Denmark in 2001 to that in 2002?
Provide a short and direct response. 1.16. What is the ratio of the Unemployed and educated female labor force (% of population) of Germany in 2001 to that in 2002?
Offer a terse response. 0.99. What is the ratio of the Unemployed and educated female labor force (% of population) in South Africa in 2001 to that in 2002?
Offer a very short reply. 0.96. What is the ratio of the Unemployed and educated female labor force (% of population) of Europe(developing only) in 2001 to that in 2003?
Your response must be concise. 0.98. What is the ratio of the Unemployed and educated female labor force (% of population) of Denmark in 2001 to that in 2003?
Keep it short and to the point. 1.34. What is the ratio of the Unemployed and educated female labor force (% of population) of Germany in 2001 to that in 2003?
Your response must be concise. 1.01. What is the ratio of the Unemployed and educated female labor force (% of population) of South Africa in 2001 to that in 2003?
Ensure brevity in your answer.  0.89. What is the ratio of the Unemployed and educated female labor force (% of population) of Europe(developing only) in 2001 to that in 2004?
Offer a very short reply. 0.98. What is the ratio of the Unemployed and educated female labor force (% of population) in Denmark in 2001 to that in 2004?
Your answer should be very brief. 1.03. What is the ratio of the Unemployed and educated female labor force (% of population) in Germany in 2001 to that in 2004?
Give a very brief answer. 1.01. What is the ratio of the Unemployed and educated female labor force (% of population) in South Africa in 2001 to that in 2004?
Your answer should be compact. 0.86. What is the ratio of the Unemployed and educated female labor force (% of population) of Germany in 2001 to that in 2005?
Keep it short and to the point. 1.02. What is the ratio of the Unemployed and educated female labor force (% of population) in South Africa in 2001 to that in 2005?
Keep it short and to the point. 0.83. What is the ratio of the Unemployed and educated female labor force (% of population) in Europe(developing only) in 2001 to that in 2006?
Your answer should be very brief. 1. What is the ratio of the Unemployed and educated female labor force (% of population) of Denmark in 2001 to that in 2006?
Your answer should be very brief. 1.35. What is the ratio of the Unemployed and educated female labor force (% of population) in Germany in 2001 to that in 2006?
Your response must be concise. 1.05. What is the ratio of the Unemployed and educated female labor force (% of population) of South Africa in 2001 to that in 2006?
Give a very brief answer. 0.85. What is the ratio of the Unemployed and educated female labor force (% of population) of Europe(developing only) in 2001 to that in 2007?
Your response must be concise. 1.02. What is the ratio of the Unemployed and educated female labor force (% of population) in Denmark in 2001 to that in 2007?
Offer a very short reply. 1.4. What is the ratio of the Unemployed and educated female labor force (% of population) in Germany in 2001 to that in 2007?
Provide a succinct answer. 1.05. What is the ratio of the Unemployed and educated female labor force (% of population) in South Africa in 2001 to that in 2007?
Give a very brief answer. 0.65. What is the ratio of the Unemployed and educated female labor force (% of population) of Europe(developing only) in 2002 to that in 2003?
Your answer should be very brief. 1.01. What is the ratio of the Unemployed and educated female labor force (% of population) in Denmark in 2002 to that in 2003?
Your answer should be very brief. 1.15. What is the ratio of the Unemployed and educated female labor force (% of population) in Germany in 2002 to that in 2003?
Make the answer very short. 1.03. What is the ratio of the Unemployed and educated female labor force (% of population) of South Africa in 2002 to that in 2003?
Give a very brief answer. 0.92. What is the ratio of the Unemployed and educated female labor force (% of population) of Denmark in 2002 to that in 2004?
Your answer should be compact. 0.88. What is the ratio of the Unemployed and educated female labor force (% of population) in Germany in 2002 to that in 2004?
Keep it short and to the point. 1.03. What is the ratio of the Unemployed and educated female labor force (% of population) of South Africa in 2002 to that in 2004?
Keep it short and to the point. 0.89. What is the ratio of the Unemployed and educated female labor force (% of population) in Europe(developing only) in 2002 to that in 2005?
Offer a terse response. 1.02. What is the ratio of the Unemployed and educated female labor force (% of population) of Denmark in 2002 to that in 2005?
Your answer should be compact. 0.94. What is the ratio of the Unemployed and educated female labor force (% of population) in Germany in 2002 to that in 2005?
Give a very brief answer. 1.04. What is the ratio of the Unemployed and educated female labor force (% of population) in South Africa in 2002 to that in 2005?
Offer a very short reply. 0.87. What is the ratio of the Unemployed and educated female labor force (% of population) in Europe(developing only) in 2002 to that in 2006?
Give a very brief answer. 1.02. What is the ratio of the Unemployed and educated female labor force (% of population) of Denmark in 2002 to that in 2006?
Give a very brief answer. 1.16. What is the ratio of the Unemployed and educated female labor force (% of population) in Germany in 2002 to that in 2006?
Your answer should be compact. 1.07. What is the ratio of the Unemployed and educated female labor force (% of population) in South Africa in 2002 to that in 2006?
Make the answer very short. 0.89. What is the ratio of the Unemployed and educated female labor force (% of population) of Europe(developing only) in 2002 to that in 2007?
Make the answer very short. 1.04. What is the ratio of the Unemployed and educated female labor force (% of population) in Denmark in 2002 to that in 2007?
Give a very brief answer. 1.2. What is the ratio of the Unemployed and educated female labor force (% of population) in Germany in 2002 to that in 2007?
Ensure brevity in your answer.  1.06. What is the ratio of the Unemployed and educated female labor force (% of population) of South Africa in 2002 to that in 2007?
Make the answer very short. 0.67. What is the ratio of the Unemployed and educated female labor force (% of population) in Denmark in 2003 to that in 2004?
Your answer should be compact. 0.77. What is the ratio of the Unemployed and educated female labor force (% of population) in Germany in 2003 to that in 2004?
Ensure brevity in your answer.  1. What is the ratio of the Unemployed and educated female labor force (% of population) of South Africa in 2003 to that in 2004?
Offer a terse response. 0.97. What is the ratio of the Unemployed and educated female labor force (% of population) in Europe(developing only) in 2003 to that in 2005?
Provide a short and direct response. 1.01. What is the ratio of the Unemployed and educated female labor force (% of population) in Denmark in 2003 to that in 2005?
Make the answer very short. 0.82. What is the ratio of the Unemployed and educated female labor force (% of population) in Germany in 2003 to that in 2005?
Offer a terse response. 1.01. What is the ratio of the Unemployed and educated female labor force (% of population) of South Africa in 2003 to that in 2005?
Give a very brief answer. 0.94. What is the ratio of the Unemployed and educated female labor force (% of population) of Europe(developing only) in 2003 to that in 2006?
Offer a terse response. 1.01. What is the ratio of the Unemployed and educated female labor force (% of population) in Germany in 2003 to that in 2006?
Ensure brevity in your answer.  1.04. What is the ratio of the Unemployed and educated female labor force (% of population) of South Africa in 2003 to that in 2006?
Offer a terse response. 0.96. What is the ratio of the Unemployed and educated female labor force (% of population) in Europe(developing only) in 2003 to that in 2007?
Your answer should be very brief. 1.03. What is the ratio of the Unemployed and educated female labor force (% of population) of Denmark in 2003 to that in 2007?
Ensure brevity in your answer.  1.05. What is the ratio of the Unemployed and educated female labor force (% of population) of Germany in 2003 to that in 2007?
Ensure brevity in your answer.  1.03. What is the ratio of the Unemployed and educated female labor force (% of population) in South Africa in 2003 to that in 2007?
Give a very brief answer. 0.73. What is the ratio of the Unemployed and educated female labor force (% of population) of Europe(developing only) in 2004 to that in 2005?
Your answer should be compact. 1.02. What is the ratio of the Unemployed and educated female labor force (% of population) in Denmark in 2004 to that in 2005?
Your response must be concise. 1.07. What is the ratio of the Unemployed and educated female labor force (% of population) of Germany in 2004 to that in 2005?
Make the answer very short. 1.01. What is the ratio of the Unemployed and educated female labor force (% of population) in South Africa in 2004 to that in 2005?
Offer a very short reply. 0.97. What is the ratio of the Unemployed and educated female labor force (% of population) in Europe(developing only) in 2004 to that in 2006?
Offer a very short reply. 1.02. What is the ratio of the Unemployed and educated female labor force (% of population) in Denmark in 2004 to that in 2006?
Your answer should be compact. 1.31. What is the ratio of the Unemployed and educated female labor force (% of population) in Germany in 2004 to that in 2006?
Your answer should be very brief. 1.04. What is the ratio of the Unemployed and educated female labor force (% of population) of Europe(developing only) in 2004 to that in 2007?
Offer a terse response. 1.04. What is the ratio of the Unemployed and educated female labor force (% of population) of Denmark in 2004 to that in 2007?
Ensure brevity in your answer.  1.36. What is the ratio of the Unemployed and educated female labor force (% of population) in Germany in 2004 to that in 2007?
Provide a short and direct response. 1.04. What is the ratio of the Unemployed and educated female labor force (% of population) of South Africa in 2004 to that in 2007?
Your answer should be compact. 0.75. What is the ratio of the Unemployed and educated female labor force (% of population) of Denmark in 2005 to that in 2006?
Keep it short and to the point. 1.23. What is the ratio of the Unemployed and educated female labor force (% of population) in Germany in 2005 to that in 2006?
Your answer should be compact. 1.03. What is the ratio of the Unemployed and educated female labor force (% of population) of South Africa in 2005 to that in 2006?
Your answer should be compact. 1.02. What is the ratio of the Unemployed and educated female labor force (% of population) in Europe(developing only) in 2005 to that in 2007?
Provide a short and direct response. 1.02. What is the ratio of the Unemployed and educated female labor force (% of population) in Denmark in 2005 to that in 2007?
Offer a terse response. 1.27. What is the ratio of the Unemployed and educated female labor force (% of population) in Germany in 2005 to that in 2007?
Provide a succinct answer. 1.02. What is the ratio of the Unemployed and educated female labor force (% of population) of South Africa in 2005 to that in 2007?
Provide a short and direct response. 0.78. What is the ratio of the Unemployed and educated female labor force (% of population) in Europe(developing only) in 2006 to that in 2007?
Provide a succinct answer. 1.02. What is the ratio of the Unemployed and educated female labor force (% of population) of Denmark in 2006 to that in 2007?
Ensure brevity in your answer.  1.04. What is the ratio of the Unemployed and educated female labor force (% of population) of Germany in 2006 to that in 2007?
Ensure brevity in your answer.  0.99. What is the ratio of the Unemployed and educated female labor force (% of population) in South Africa in 2006 to that in 2007?
Your response must be concise. 0.76. What is the difference between the highest and the second highest Unemployed and educated female labor force (% of population) in Europe(developing only)?
Give a very brief answer. 1.67. What is the difference between the highest and the lowest Unemployed and educated female labor force (% of population) in Europe(developing only)?
Keep it short and to the point. 3.63. What is the difference between the highest and the lowest Unemployed and educated female labor force (% of population) of Denmark?
Provide a short and direct response. 14.8. What is the difference between the highest and the lowest Unemployed and educated female labor force (% of population) in Germany?
Keep it short and to the point. 3.9. What is the difference between the highest and the lowest Unemployed and educated female labor force (% of population) of South Africa?
Keep it short and to the point. 23.1. 